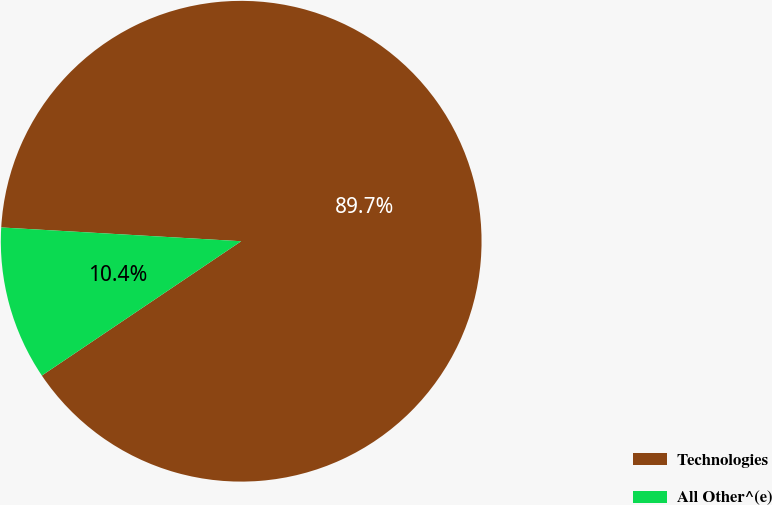<chart> <loc_0><loc_0><loc_500><loc_500><pie_chart><fcel>Technologies<fcel>All Other^(e)<nl><fcel>89.65%<fcel>10.35%<nl></chart> 